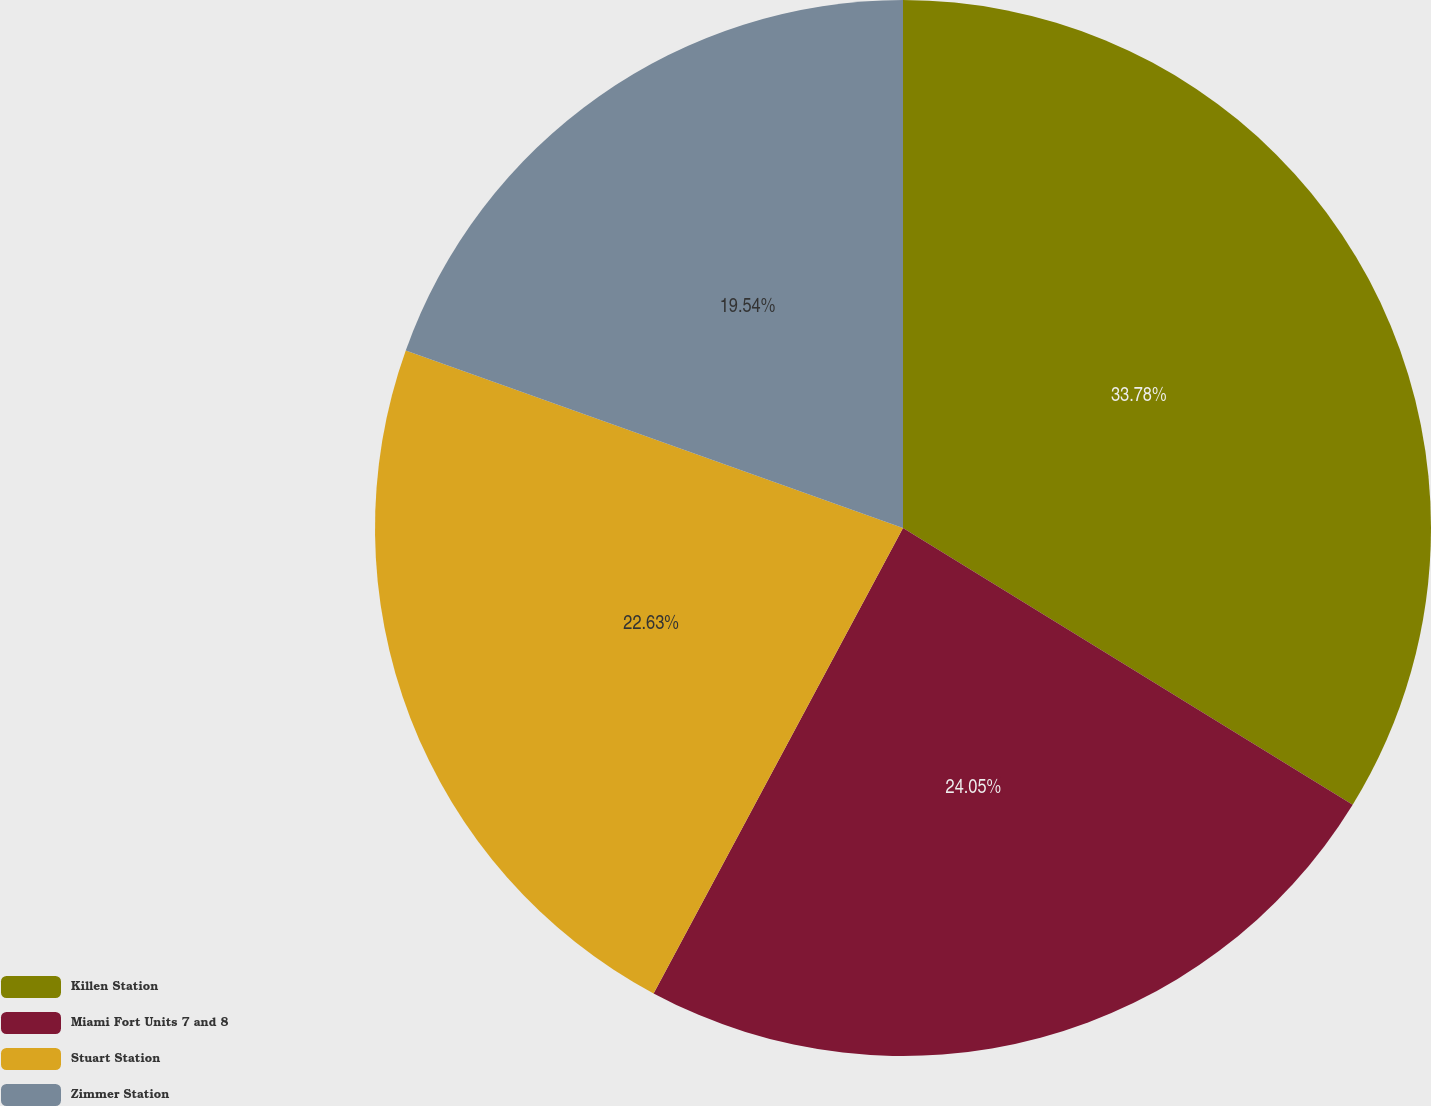Convert chart. <chart><loc_0><loc_0><loc_500><loc_500><pie_chart><fcel>Killen Station<fcel>Miami Fort Units 7 and 8<fcel>Stuart Station<fcel>Zimmer Station<nl><fcel>33.78%<fcel>24.05%<fcel>22.63%<fcel>19.54%<nl></chart> 